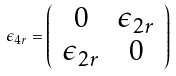<formula> <loc_0><loc_0><loc_500><loc_500>\epsilon _ { 4 r } = \left ( \begin{array} { c c } 0 & { \epsilon } _ { 2 r } \\ { \epsilon } _ { 2 r } & 0 \end{array} \right )</formula> 